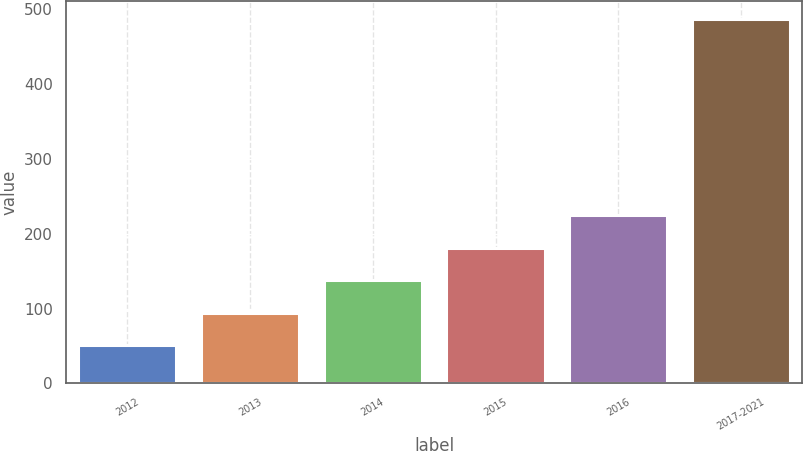<chart> <loc_0><loc_0><loc_500><loc_500><bar_chart><fcel>2012<fcel>2013<fcel>2014<fcel>2015<fcel>2016<fcel>2017-2021<nl><fcel>50.9<fcel>94.46<fcel>138.02<fcel>181.58<fcel>225.14<fcel>486.5<nl></chart> 